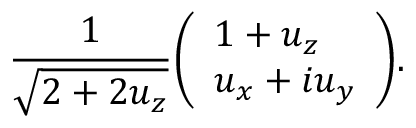<formula> <loc_0><loc_0><loc_500><loc_500>{ \frac { 1 } { \sqrt { 2 + 2 u _ { z } } } } { \left ( \begin{array} { l } { 1 + u _ { z } } \\ { u _ { x } + i u _ { y } } \end{array} \right ) } .</formula> 